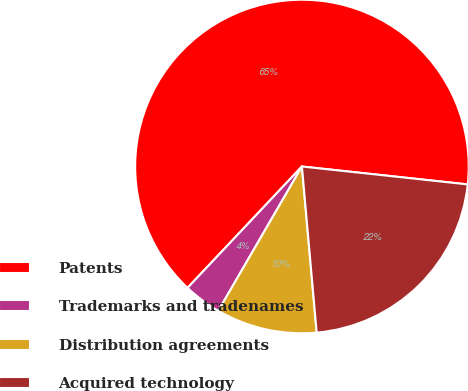<chart> <loc_0><loc_0><loc_500><loc_500><pie_chart><fcel>Patents<fcel>Trademarks and tradenames<fcel>Distribution agreements<fcel>Acquired technology<nl><fcel>64.69%<fcel>3.67%<fcel>9.77%<fcel>21.88%<nl></chart> 